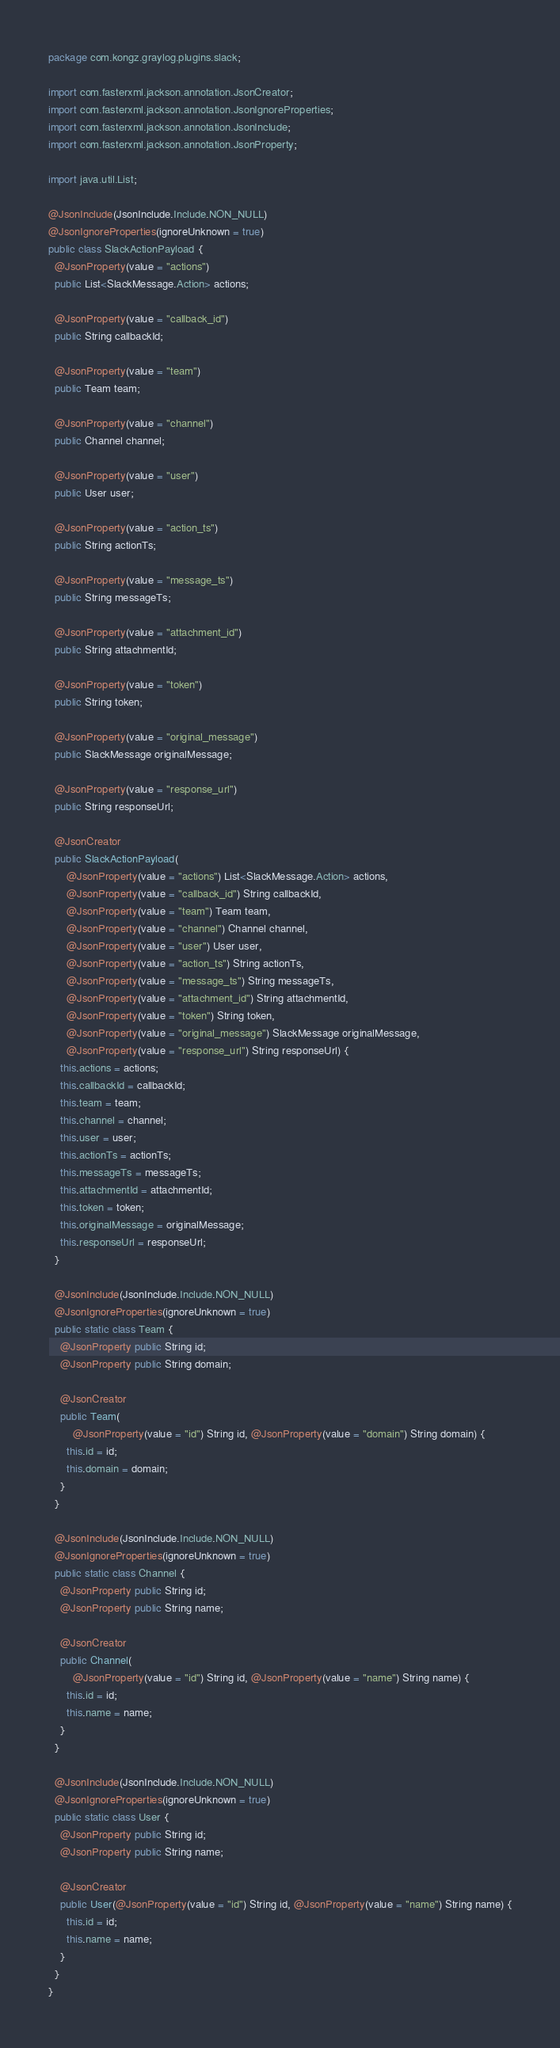<code> <loc_0><loc_0><loc_500><loc_500><_Java_>package com.kongz.graylog.plugins.slack;

import com.fasterxml.jackson.annotation.JsonCreator;
import com.fasterxml.jackson.annotation.JsonIgnoreProperties;
import com.fasterxml.jackson.annotation.JsonInclude;
import com.fasterxml.jackson.annotation.JsonProperty;

import java.util.List;

@JsonInclude(JsonInclude.Include.NON_NULL)
@JsonIgnoreProperties(ignoreUnknown = true)
public class SlackActionPayload {
  @JsonProperty(value = "actions")
  public List<SlackMessage.Action> actions;

  @JsonProperty(value = "callback_id")
  public String callbackId;

  @JsonProperty(value = "team")
  public Team team;

  @JsonProperty(value = "channel")
  public Channel channel;

  @JsonProperty(value = "user")
  public User user;

  @JsonProperty(value = "action_ts")
  public String actionTs;

  @JsonProperty(value = "message_ts")
  public String messageTs;

  @JsonProperty(value = "attachment_id")
  public String attachmentId;

  @JsonProperty(value = "token")
  public String token;

  @JsonProperty(value = "original_message")
  public SlackMessage originalMessage;

  @JsonProperty(value = "response_url")
  public String responseUrl;

  @JsonCreator
  public SlackActionPayload(
      @JsonProperty(value = "actions") List<SlackMessage.Action> actions,
      @JsonProperty(value = "callback_id") String callbackId,
      @JsonProperty(value = "team") Team team,
      @JsonProperty(value = "channel") Channel channel,
      @JsonProperty(value = "user") User user,
      @JsonProperty(value = "action_ts") String actionTs,
      @JsonProperty(value = "message_ts") String messageTs,
      @JsonProperty(value = "attachment_id") String attachmentId,
      @JsonProperty(value = "token") String token,
      @JsonProperty(value = "original_message") SlackMessage originalMessage,
      @JsonProperty(value = "response_url") String responseUrl) {
    this.actions = actions;
    this.callbackId = callbackId;
    this.team = team;
    this.channel = channel;
    this.user = user;
    this.actionTs = actionTs;
    this.messageTs = messageTs;
    this.attachmentId = attachmentId;
    this.token = token;
    this.originalMessage = originalMessage;
    this.responseUrl = responseUrl;
  }

  @JsonInclude(JsonInclude.Include.NON_NULL)
  @JsonIgnoreProperties(ignoreUnknown = true)
  public static class Team {
    @JsonProperty public String id;
    @JsonProperty public String domain;

    @JsonCreator
    public Team(
        @JsonProperty(value = "id") String id, @JsonProperty(value = "domain") String domain) {
      this.id = id;
      this.domain = domain;
    }
  }

  @JsonInclude(JsonInclude.Include.NON_NULL)
  @JsonIgnoreProperties(ignoreUnknown = true)
  public static class Channel {
    @JsonProperty public String id;
    @JsonProperty public String name;

    @JsonCreator
    public Channel(
        @JsonProperty(value = "id") String id, @JsonProperty(value = "name") String name) {
      this.id = id;
      this.name = name;
    }
  }

  @JsonInclude(JsonInclude.Include.NON_NULL)
  @JsonIgnoreProperties(ignoreUnknown = true)
  public static class User {
    @JsonProperty public String id;
    @JsonProperty public String name;

    @JsonCreator
    public User(@JsonProperty(value = "id") String id, @JsonProperty(value = "name") String name) {
      this.id = id;
      this.name = name;
    }
  }
}
</code> 